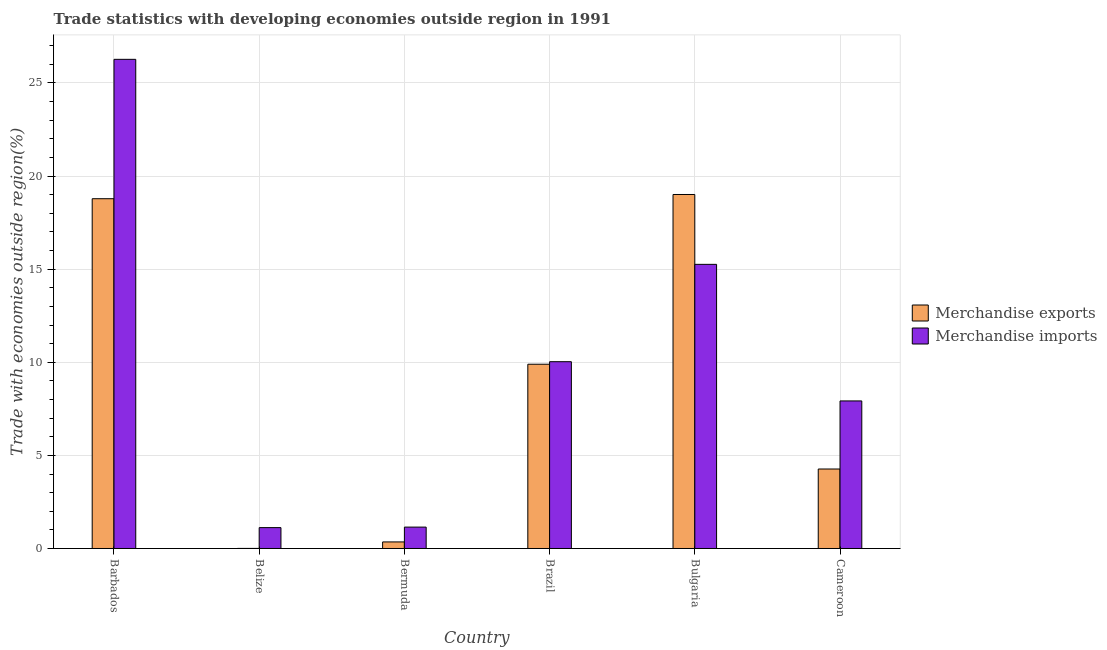How many different coloured bars are there?
Your answer should be very brief. 2. Are the number of bars per tick equal to the number of legend labels?
Keep it short and to the point. Yes. How many bars are there on the 5th tick from the right?
Provide a succinct answer. 2. What is the label of the 2nd group of bars from the left?
Give a very brief answer. Belize. What is the merchandise exports in Brazil?
Keep it short and to the point. 9.9. Across all countries, what is the maximum merchandise exports?
Offer a very short reply. 19.01. Across all countries, what is the minimum merchandise exports?
Give a very brief answer. 0. In which country was the merchandise imports minimum?
Provide a succinct answer. Belize. What is the total merchandise exports in the graph?
Offer a terse response. 52.31. What is the difference between the merchandise imports in Belize and that in Bulgaria?
Ensure brevity in your answer.  -14.14. What is the difference between the merchandise exports in Cameroon and the merchandise imports in Barbados?
Provide a short and direct response. -22. What is the average merchandise imports per country?
Offer a terse response. 10.29. What is the difference between the merchandise imports and merchandise exports in Bulgaria?
Give a very brief answer. -3.75. What is the ratio of the merchandise imports in Belize to that in Cameroon?
Offer a terse response. 0.14. What is the difference between the highest and the second highest merchandise exports?
Provide a short and direct response. 0.23. What is the difference between the highest and the lowest merchandise exports?
Your answer should be very brief. 19.01. In how many countries, is the merchandise imports greater than the average merchandise imports taken over all countries?
Your answer should be very brief. 2. What does the 2nd bar from the left in Barbados represents?
Keep it short and to the point. Merchandise imports. How many countries are there in the graph?
Provide a short and direct response. 6. What is the difference between two consecutive major ticks on the Y-axis?
Give a very brief answer. 5. Does the graph contain grids?
Your response must be concise. Yes. How many legend labels are there?
Provide a succinct answer. 2. What is the title of the graph?
Your answer should be compact. Trade statistics with developing economies outside region in 1991. What is the label or title of the Y-axis?
Your response must be concise. Trade with economies outside region(%). What is the Trade with economies outside region(%) of Merchandise exports in Barbados?
Provide a succinct answer. 18.78. What is the Trade with economies outside region(%) of Merchandise imports in Barbados?
Your response must be concise. 26.27. What is the Trade with economies outside region(%) of Merchandise exports in Belize?
Your answer should be very brief. 0. What is the Trade with economies outside region(%) of Merchandise imports in Belize?
Make the answer very short. 1.12. What is the Trade with economies outside region(%) of Merchandise exports in Bermuda?
Provide a short and direct response. 0.35. What is the Trade with economies outside region(%) in Merchandise imports in Bermuda?
Provide a succinct answer. 1.15. What is the Trade with economies outside region(%) of Merchandise exports in Brazil?
Your answer should be very brief. 9.9. What is the Trade with economies outside region(%) of Merchandise imports in Brazil?
Your answer should be very brief. 10.03. What is the Trade with economies outside region(%) in Merchandise exports in Bulgaria?
Make the answer very short. 19.01. What is the Trade with economies outside region(%) in Merchandise imports in Bulgaria?
Provide a short and direct response. 15.26. What is the Trade with economies outside region(%) in Merchandise exports in Cameroon?
Offer a very short reply. 4.27. What is the Trade with economies outside region(%) in Merchandise imports in Cameroon?
Give a very brief answer. 7.92. Across all countries, what is the maximum Trade with economies outside region(%) of Merchandise exports?
Keep it short and to the point. 19.01. Across all countries, what is the maximum Trade with economies outside region(%) in Merchandise imports?
Your response must be concise. 26.27. Across all countries, what is the minimum Trade with economies outside region(%) in Merchandise exports?
Provide a short and direct response. 0. Across all countries, what is the minimum Trade with economies outside region(%) of Merchandise imports?
Offer a terse response. 1.12. What is the total Trade with economies outside region(%) of Merchandise exports in the graph?
Your response must be concise. 52.31. What is the total Trade with economies outside region(%) of Merchandise imports in the graph?
Offer a terse response. 61.75. What is the difference between the Trade with economies outside region(%) of Merchandise exports in Barbados and that in Belize?
Give a very brief answer. 18.78. What is the difference between the Trade with economies outside region(%) in Merchandise imports in Barbados and that in Belize?
Provide a short and direct response. 25.15. What is the difference between the Trade with economies outside region(%) in Merchandise exports in Barbados and that in Bermuda?
Make the answer very short. 18.43. What is the difference between the Trade with economies outside region(%) of Merchandise imports in Barbados and that in Bermuda?
Provide a short and direct response. 25.12. What is the difference between the Trade with economies outside region(%) in Merchandise exports in Barbados and that in Brazil?
Ensure brevity in your answer.  8.89. What is the difference between the Trade with economies outside region(%) of Merchandise imports in Barbados and that in Brazil?
Make the answer very short. 16.24. What is the difference between the Trade with economies outside region(%) in Merchandise exports in Barbados and that in Bulgaria?
Offer a terse response. -0.23. What is the difference between the Trade with economies outside region(%) of Merchandise imports in Barbados and that in Bulgaria?
Provide a short and direct response. 11.01. What is the difference between the Trade with economies outside region(%) in Merchandise exports in Barbados and that in Cameroon?
Provide a short and direct response. 14.52. What is the difference between the Trade with economies outside region(%) in Merchandise imports in Barbados and that in Cameroon?
Make the answer very short. 18.34. What is the difference between the Trade with economies outside region(%) in Merchandise exports in Belize and that in Bermuda?
Provide a succinct answer. -0.35. What is the difference between the Trade with economies outside region(%) of Merchandise imports in Belize and that in Bermuda?
Your answer should be very brief. -0.03. What is the difference between the Trade with economies outside region(%) of Merchandise exports in Belize and that in Brazil?
Offer a terse response. -9.89. What is the difference between the Trade with economies outside region(%) in Merchandise imports in Belize and that in Brazil?
Provide a short and direct response. -8.91. What is the difference between the Trade with economies outside region(%) of Merchandise exports in Belize and that in Bulgaria?
Your answer should be compact. -19.01. What is the difference between the Trade with economies outside region(%) of Merchandise imports in Belize and that in Bulgaria?
Provide a short and direct response. -14.14. What is the difference between the Trade with economies outside region(%) in Merchandise exports in Belize and that in Cameroon?
Give a very brief answer. -4.26. What is the difference between the Trade with economies outside region(%) in Merchandise imports in Belize and that in Cameroon?
Your answer should be very brief. -6.8. What is the difference between the Trade with economies outside region(%) in Merchandise exports in Bermuda and that in Brazil?
Your response must be concise. -9.54. What is the difference between the Trade with economies outside region(%) of Merchandise imports in Bermuda and that in Brazil?
Your answer should be compact. -8.88. What is the difference between the Trade with economies outside region(%) in Merchandise exports in Bermuda and that in Bulgaria?
Make the answer very short. -18.66. What is the difference between the Trade with economies outside region(%) of Merchandise imports in Bermuda and that in Bulgaria?
Make the answer very short. -14.11. What is the difference between the Trade with economies outside region(%) in Merchandise exports in Bermuda and that in Cameroon?
Give a very brief answer. -3.92. What is the difference between the Trade with economies outside region(%) of Merchandise imports in Bermuda and that in Cameroon?
Your response must be concise. -6.78. What is the difference between the Trade with economies outside region(%) of Merchandise exports in Brazil and that in Bulgaria?
Offer a very short reply. -9.12. What is the difference between the Trade with economies outside region(%) in Merchandise imports in Brazil and that in Bulgaria?
Your answer should be very brief. -5.23. What is the difference between the Trade with economies outside region(%) of Merchandise exports in Brazil and that in Cameroon?
Your response must be concise. 5.63. What is the difference between the Trade with economies outside region(%) in Merchandise imports in Brazil and that in Cameroon?
Your answer should be very brief. 2.11. What is the difference between the Trade with economies outside region(%) of Merchandise exports in Bulgaria and that in Cameroon?
Make the answer very short. 14.74. What is the difference between the Trade with economies outside region(%) of Merchandise imports in Bulgaria and that in Cameroon?
Offer a terse response. 7.33. What is the difference between the Trade with economies outside region(%) of Merchandise exports in Barbados and the Trade with economies outside region(%) of Merchandise imports in Belize?
Your answer should be very brief. 17.66. What is the difference between the Trade with economies outside region(%) of Merchandise exports in Barbados and the Trade with economies outside region(%) of Merchandise imports in Bermuda?
Provide a short and direct response. 17.64. What is the difference between the Trade with economies outside region(%) in Merchandise exports in Barbados and the Trade with economies outside region(%) in Merchandise imports in Brazil?
Your response must be concise. 8.75. What is the difference between the Trade with economies outside region(%) in Merchandise exports in Barbados and the Trade with economies outside region(%) in Merchandise imports in Bulgaria?
Give a very brief answer. 3.52. What is the difference between the Trade with economies outside region(%) in Merchandise exports in Barbados and the Trade with economies outside region(%) in Merchandise imports in Cameroon?
Ensure brevity in your answer.  10.86. What is the difference between the Trade with economies outside region(%) of Merchandise exports in Belize and the Trade with economies outside region(%) of Merchandise imports in Bermuda?
Ensure brevity in your answer.  -1.14. What is the difference between the Trade with economies outside region(%) of Merchandise exports in Belize and the Trade with economies outside region(%) of Merchandise imports in Brazil?
Provide a succinct answer. -10.03. What is the difference between the Trade with economies outside region(%) in Merchandise exports in Belize and the Trade with economies outside region(%) in Merchandise imports in Bulgaria?
Offer a very short reply. -15.25. What is the difference between the Trade with economies outside region(%) in Merchandise exports in Belize and the Trade with economies outside region(%) in Merchandise imports in Cameroon?
Offer a very short reply. -7.92. What is the difference between the Trade with economies outside region(%) in Merchandise exports in Bermuda and the Trade with economies outside region(%) in Merchandise imports in Brazil?
Your response must be concise. -9.68. What is the difference between the Trade with economies outside region(%) in Merchandise exports in Bermuda and the Trade with economies outside region(%) in Merchandise imports in Bulgaria?
Provide a succinct answer. -14.91. What is the difference between the Trade with economies outside region(%) of Merchandise exports in Bermuda and the Trade with economies outside region(%) of Merchandise imports in Cameroon?
Provide a short and direct response. -7.57. What is the difference between the Trade with economies outside region(%) of Merchandise exports in Brazil and the Trade with economies outside region(%) of Merchandise imports in Bulgaria?
Your response must be concise. -5.36. What is the difference between the Trade with economies outside region(%) in Merchandise exports in Brazil and the Trade with economies outside region(%) in Merchandise imports in Cameroon?
Your answer should be very brief. 1.97. What is the difference between the Trade with economies outside region(%) of Merchandise exports in Bulgaria and the Trade with economies outside region(%) of Merchandise imports in Cameroon?
Your answer should be compact. 11.09. What is the average Trade with economies outside region(%) in Merchandise exports per country?
Your response must be concise. 8.72. What is the average Trade with economies outside region(%) of Merchandise imports per country?
Provide a succinct answer. 10.29. What is the difference between the Trade with economies outside region(%) of Merchandise exports and Trade with economies outside region(%) of Merchandise imports in Barbados?
Offer a very short reply. -7.49. What is the difference between the Trade with economies outside region(%) of Merchandise exports and Trade with economies outside region(%) of Merchandise imports in Belize?
Keep it short and to the point. -1.12. What is the difference between the Trade with economies outside region(%) of Merchandise exports and Trade with economies outside region(%) of Merchandise imports in Bermuda?
Your answer should be very brief. -0.8. What is the difference between the Trade with economies outside region(%) in Merchandise exports and Trade with economies outside region(%) in Merchandise imports in Brazil?
Provide a succinct answer. -0.14. What is the difference between the Trade with economies outside region(%) in Merchandise exports and Trade with economies outside region(%) in Merchandise imports in Bulgaria?
Provide a short and direct response. 3.75. What is the difference between the Trade with economies outside region(%) in Merchandise exports and Trade with economies outside region(%) in Merchandise imports in Cameroon?
Provide a short and direct response. -3.66. What is the ratio of the Trade with economies outside region(%) in Merchandise exports in Barbados to that in Belize?
Your response must be concise. 4290.5. What is the ratio of the Trade with economies outside region(%) in Merchandise imports in Barbados to that in Belize?
Keep it short and to the point. 23.43. What is the ratio of the Trade with economies outside region(%) in Merchandise exports in Barbados to that in Bermuda?
Provide a short and direct response. 53.39. What is the ratio of the Trade with economies outside region(%) in Merchandise imports in Barbados to that in Bermuda?
Your response must be concise. 22.88. What is the ratio of the Trade with economies outside region(%) in Merchandise exports in Barbados to that in Brazil?
Provide a short and direct response. 1.9. What is the ratio of the Trade with economies outside region(%) in Merchandise imports in Barbados to that in Brazil?
Your answer should be very brief. 2.62. What is the ratio of the Trade with economies outside region(%) in Merchandise exports in Barbados to that in Bulgaria?
Keep it short and to the point. 0.99. What is the ratio of the Trade with economies outside region(%) in Merchandise imports in Barbados to that in Bulgaria?
Make the answer very short. 1.72. What is the ratio of the Trade with economies outside region(%) in Merchandise exports in Barbados to that in Cameroon?
Keep it short and to the point. 4.4. What is the ratio of the Trade with economies outside region(%) in Merchandise imports in Barbados to that in Cameroon?
Your answer should be very brief. 3.31. What is the ratio of the Trade with economies outside region(%) in Merchandise exports in Belize to that in Bermuda?
Ensure brevity in your answer.  0.01. What is the ratio of the Trade with economies outside region(%) of Merchandise imports in Belize to that in Bermuda?
Provide a short and direct response. 0.98. What is the ratio of the Trade with economies outside region(%) of Merchandise imports in Belize to that in Brazil?
Your response must be concise. 0.11. What is the ratio of the Trade with economies outside region(%) in Merchandise exports in Belize to that in Bulgaria?
Provide a succinct answer. 0. What is the ratio of the Trade with economies outside region(%) in Merchandise imports in Belize to that in Bulgaria?
Provide a short and direct response. 0.07. What is the ratio of the Trade with economies outside region(%) of Merchandise exports in Belize to that in Cameroon?
Give a very brief answer. 0. What is the ratio of the Trade with economies outside region(%) of Merchandise imports in Belize to that in Cameroon?
Ensure brevity in your answer.  0.14. What is the ratio of the Trade with economies outside region(%) in Merchandise exports in Bermuda to that in Brazil?
Provide a short and direct response. 0.04. What is the ratio of the Trade with economies outside region(%) of Merchandise imports in Bermuda to that in Brazil?
Your answer should be very brief. 0.11. What is the ratio of the Trade with economies outside region(%) in Merchandise exports in Bermuda to that in Bulgaria?
Your answer should be compact. 0.02. What is the ratio of the Trade with economies outside region(%) in Merchandise imports in Bermuda to that in Bulgaria?
Your answer should be compact. 0.08. What is the ratio of the Trade with economies outside region(%) in Merchandise exports in Bermuda to that in Cameroon?
Keep it short and to the point. 0.08. What is the ratio of the Trade with economies outside region(%) in Merchandise imports in Bermuda to that in Cameroon?
Keep it short and to the point. 0.14. What is the ratio of the Trade with economies outside region(%) in Merchandise exports in Brazil to that in Bulgaria?
Offer a terse response. 0.52. What is the ratio of the Trade with economies outside region(%) in Merchandise imports in Brazil to that in Bulgaria?
Give a very brief answer. 0.66. What is the ratio of the Trade with economies outside region(%) of Merchandise exports in Brazil to that in Cameroon?
Ensure brevity in your answer.  2.32. What is the ratio of the Trade with economies outside region(%) in Merchandise imports in Brazil to that in Cameroon?
Offer a terse response. 1.27. What is the ratio of the Trade with economies outside region(%) of Merchandise exports in Bulgaria to that in Cameroon?
Offer a terse response. 4.45. What is the ratio of the Trade with economies outside region(%) of Merchandise imports in Bulgaria to that in Cameroon?
Your answer should be compact. 1.93. What is the difference between the highest and the second highest Trade with economies outside region(%) in Merchandise exports?
Offer a very short reply. 0.23. What is the difference between the highest and the second highest Trade with economies outside region(%) of Merchandise imports?
Give a very brief answer. 11.01. What is the difference between the highest and the lowest Trade with economies outside region(%) of Merchandise exports?
Offer a very short reply. 19.01. What is the difference between the highest and the lowest Trade with economies outside region(%) in Merchandise imports?
Provide a short and direct response. 25.15. 